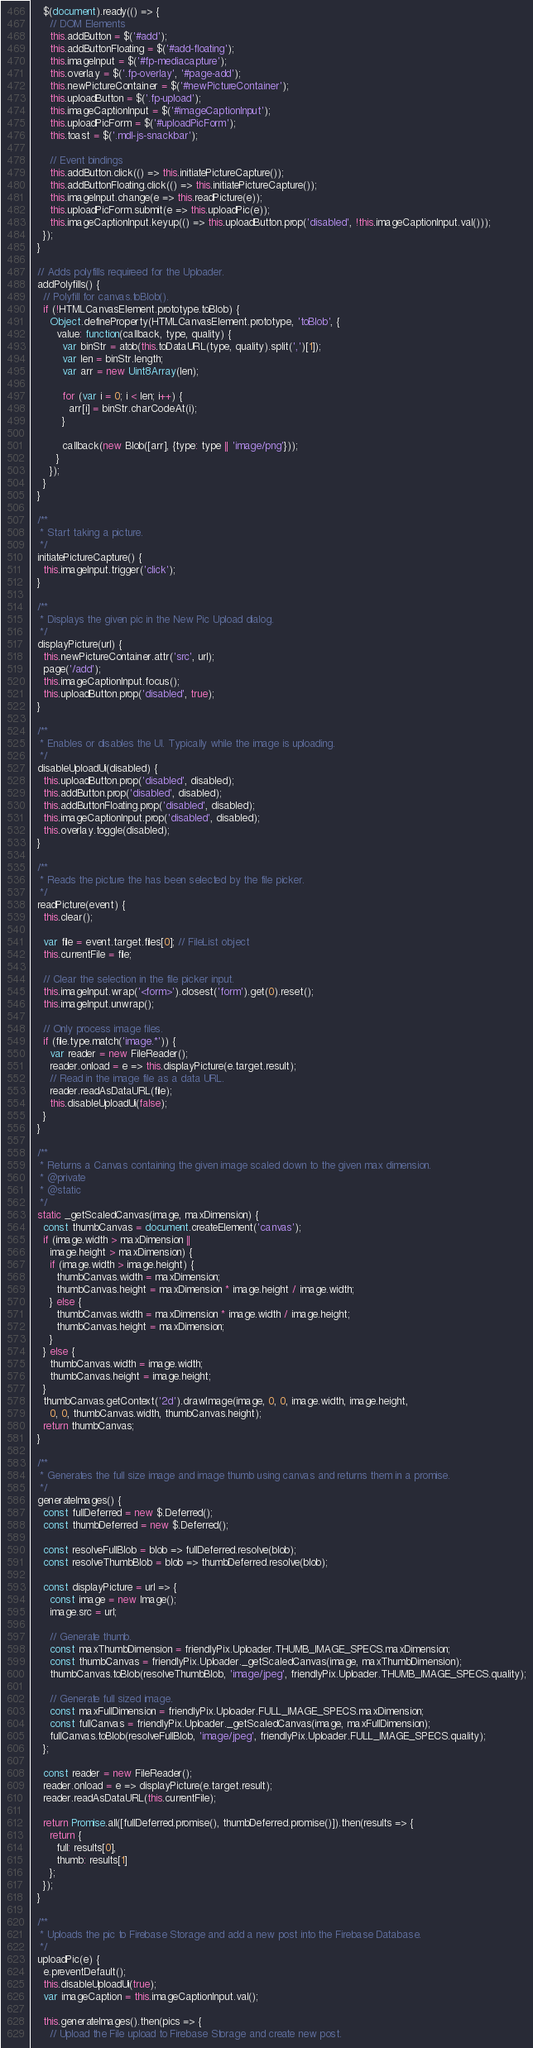Convert code to text. <code><loc_0><loc_0><loc_500><loc_500><_JavaScript_>    $(document).ready(() => {
      // DOM Elements
      this.addButton = $('#add');
      this.addButtonFloating = $('#add-floating');
      this.imageInput = $('#fp-mediacapture');
      this.overlay = $('.fp-overlay', '#page-add');
      this.newPictureContainer = $('#newPictureContainer');
      this.uploadButton = $('.fp-upload');
      this.imageCaptionInput = $('#imageCaptionInput');
      this.uploadPicForm = $('#uploadPicForm');
      this.toast = $('.mdl-js-snackbar');

      // Event bindings
      this.addButton.click(() => this.initiatePictureCapture());
      this.addButtonFloating.click(() => this.initiatePictureCapture());
      this.imageInput.change(e => this.readPicture(e));
      this.uploadPicForm.submit(e => this.uploadPic(e));
      this.imageCaptionInput.keyup(() => this.uploadButton.prop('disabled', !this.imageCaptionInput.val()));
    });
  }

  // Adds polyfills requireed for the Uploader.
  addPolyfills() {
    // Polyfill for canvas.toBlob().
    if (!HTMLCanvasElement.prototype.toBlob) {
      Object.defineProperty(HTMLCanvasElement.prototype, 'toBlob', {
        value: function(callback, type, quality) {
          var binStr = atob(this.toDataURL(type, quality).split(',')[1]);
          var len = binStr.length;
          var arr = new Uint8Array(len);

          for (var i = 0; i < len; i++) {
            arr[i] = binStr.charCodeAt(i);
          }

          callback(new Blob([arr], {type: type || 'image/png'}));
        }
      });
    }
  }

  /**
   * Start taking a picture.
   */
  initiatePictureCapture() {
    this.imageInput.trigger('click');
  }

  /**
   * Displays the given pic in the New Pic Upload dialog.
   */
  displayPicture(url) {
    this.newPictureContainer.attr('src', url);
    page('/add');
    this.imageCaptionInput.focus();
    this.uploadButton.prop('disabled', true);
  }

  /**
   * Enables or disables the UI. Typically while the image is uploading.
   */
  disableUploadUi(disabled) {
    this.uploadButton.prop('disabled', disabled);
    this.addButton.prop('disabled', disabled);
    this.addButtonFloating.prop('disabled', disabled);
    this.imageCaptionInput.prop('disabled', disabled);
    this.overlay.toggle(disabled);
  }

  /**
   * Reads the picture the has been selected by the file picker.
   */
  readPicture(event) {
    this.clear();

    var file = event.target.files[0]; // FileList object
    this.currentFile = file;

    // Clear the selection in the file picker input.
    this.imageInput.wrap('<form>').closest('form').get(0).reset();
    this.imageInput.unwrap();

    // Only process image files.
    if (file.type.match('image.*')) {
      var reader = new FileReader();
      reader.onload = e => this.displayPicture(e.target.result);
      // Read in the image file as a data URL.
      reader.readAsDataURL(file);
      this.disableUploadUi(false);
    }
  }

  /**
   * Returns a Canvas containing the given image scaled down to the given max dimension.
   * @private
   * @static
   */
  static _getScaledCanvas(image, maxDimension) {
    const thumbCanvas = document.createElement('canvas');
    if (image.width > maxDimension ||
      image.height > maxDimension) {
      if (image.width > image.height) {
        thumbCanvas.width = maxDimension;
        thumbCanvas.height = maxDimension * image.height / image.width;
      } else {
        thumbCanvas.width = maxDimension * image.width / image.height;
        thumbCanvas.height = maxDimension;
      }
    } else {
      thumbCanvas.width = image.width;
      thumbCanvas.height = image.height;
    }
    thumbCanvas.getContext('2d').drawImage(image, 0, 0, image.width, image.height,
      0, 0, thumbCanvas.width, thumbCanvas.height);
    return thumbCanvas;
  }

  /**
   * Generates the full size image and image thumb using canvas and returns them in a promise.
   */
  generateImages() {
    const fullDeferred = new $.Deferred();
    const thumbDeferred = new $.Deferred();

    const resolveFullBlob = blob => fullDeferred.resolve(blob);
    const resolveThumbBlob = blob => thumbDeferred.resolve(blob);

    const displayPicture = url => {
      const image = new Image();
      image.src = url;

      // Generate thumb.
      const maxThumbDimension = friendlyPix.Uploader.THUMB_IMAGE_SPECS.maxDimension;
      const thumbCanvas = friendlyPix.Uploader._getScaledCanvas(image, maxThumbDimension);
      thumbCanvas.toBlob(resolveThumbBlob, 'image/jpeg', friendlyPix.Uploader.THUMB_IMAGE_SPECS.quality);

      // Generate full sized image.
      const maxFullDimension = friendlyPix.Uploader.FULL_IMAGE_SPECS.maxDimension;
      const fullCanvas = friendlyPix.Uploader._getScaledCanvas(image, maxFullDimension);
      fullCanvas.toBlob(resolveFullBlob, 'image/jpeg', friendlyPix.Uploader.FULL_IMAGE_SPECS.quality);
    };

    const reader = new FileReader();
    reader.onload = e => displayPicture(e.target.result);
    reader.readAsDataURL(this.currentFile);

    return Promise.all([fullDeferred.promise(), thumbDeferred.promise()]).then(results => {
      return {
        full: results[0],
        thumb: results[1]
      };
    });
  }

  /**
   * Uploads the pic to Firebase Storage and add a new post into the Firebase Database.
   */
  uploadPic(e) {
    e.preventDefault();
    this.disableUploadUi(true);
    var imageCaption = this.imageCaptionInput.val();

    this.generateImages().then(pics => {
      // Upload the File upload to Firebase Storage and create new post.</code> 